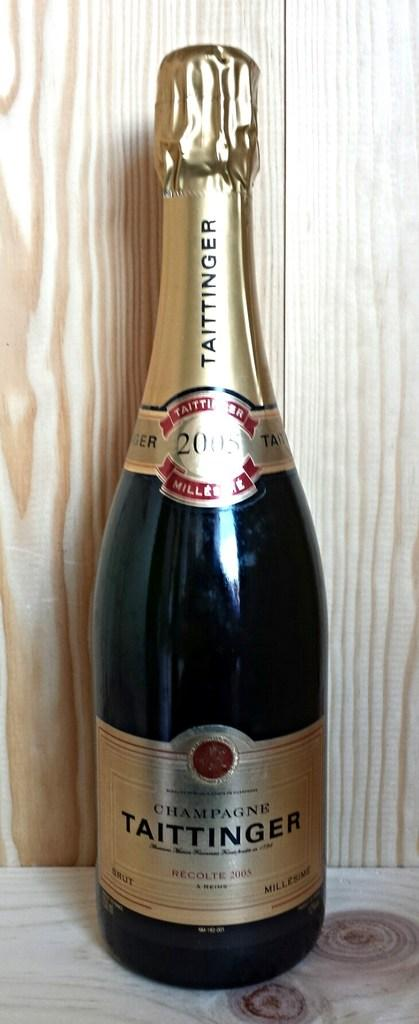Provide a one-sentence caption for the provided image. A champagne bottle of Taittinger is on display with a wooden base and wooden background. 